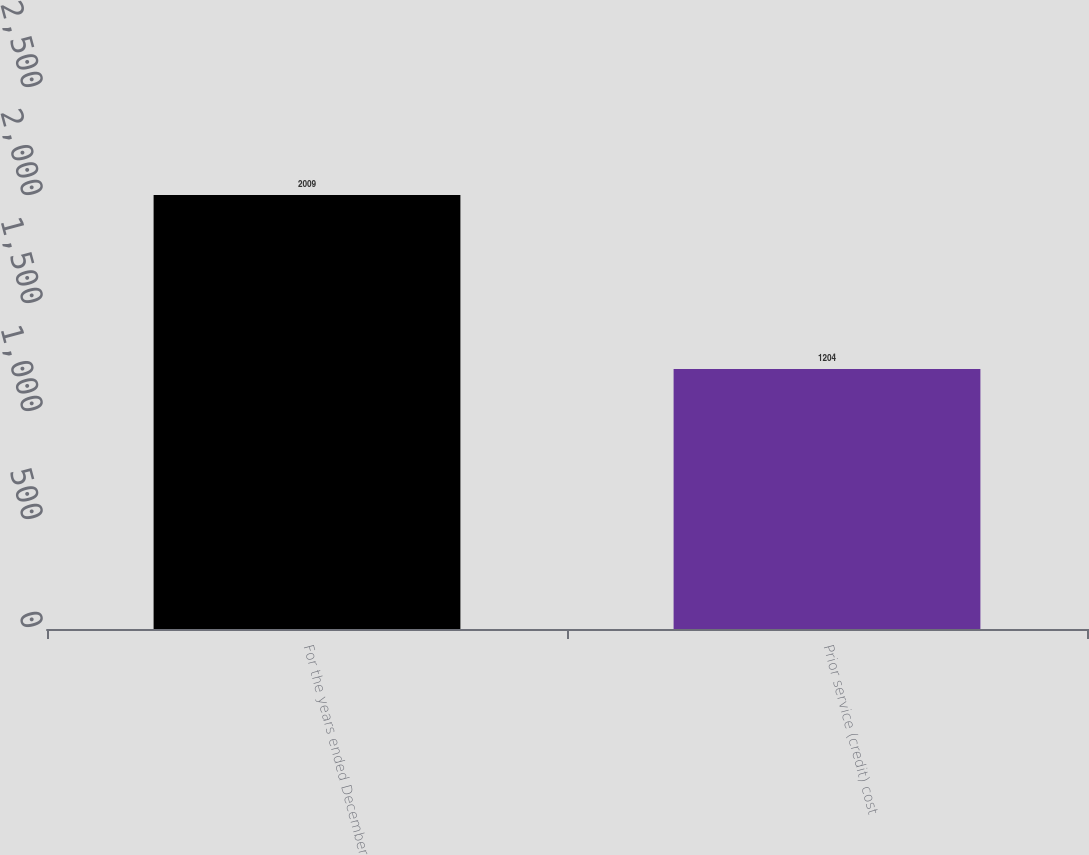<chart> <loc_0><loc_0><loc_500><loc_500><bar_chart><fcel>For the years ended December<fcel>Prior service (credit) cost<nl><fcel>2009<fcel>1204<nl></chart> 